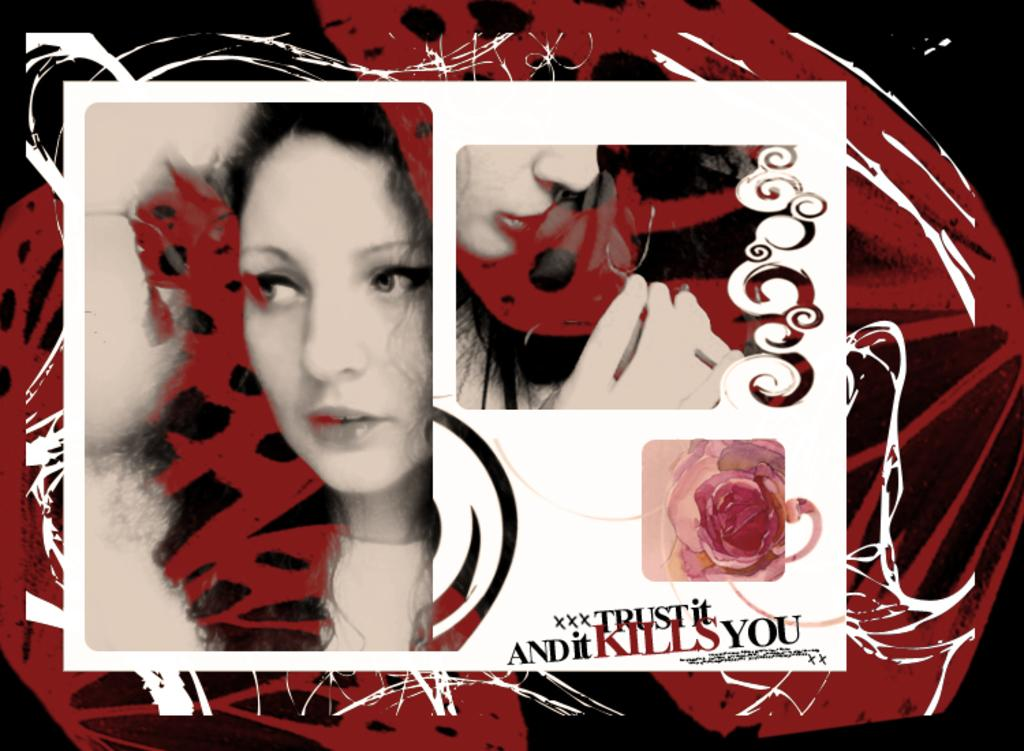Who is the main subject in the picture? There is an image of a woman in the picture. What is the woman doing in the image? The woman is looking to the left. What can be found at the bottom of the image? There is text written at the bottom of the image. What colors are used for the backdrop of the image? The backdrop of the image is black and red. What type of fruit is being stored in the drawer in the image? There is no drawer or fruit present in the image. 